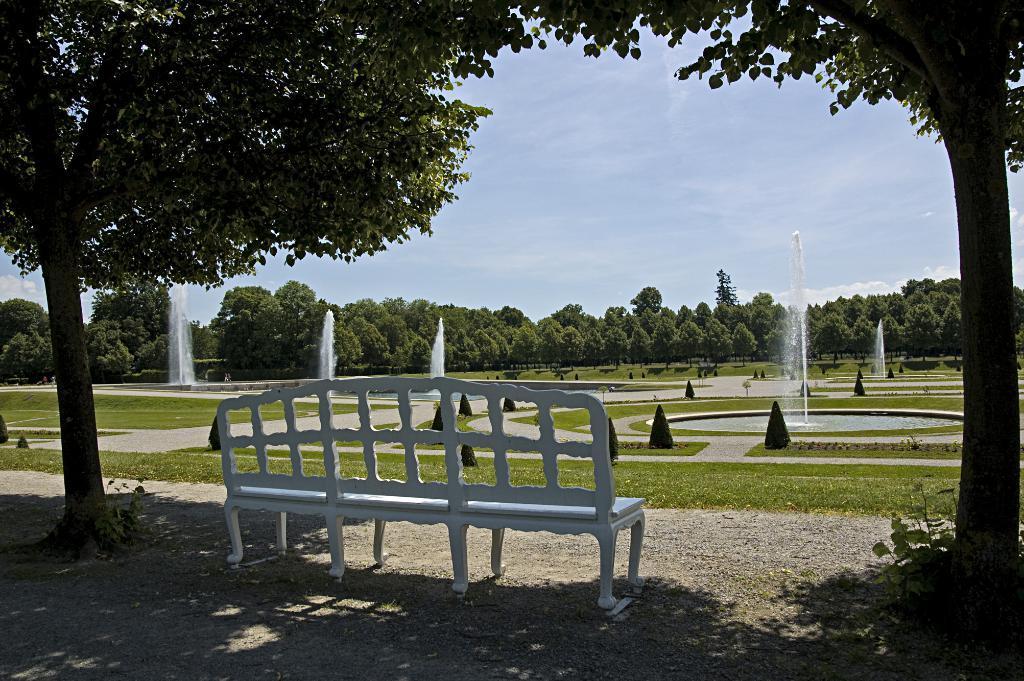Describe this image in one or two sentences. In this image there is a bench on the ground. On the either sides of the bench there are trees. In front of the bench there's grass on the ground. There are fountains and plants on the ground. In the background there are trees. At the top there is the sky. 